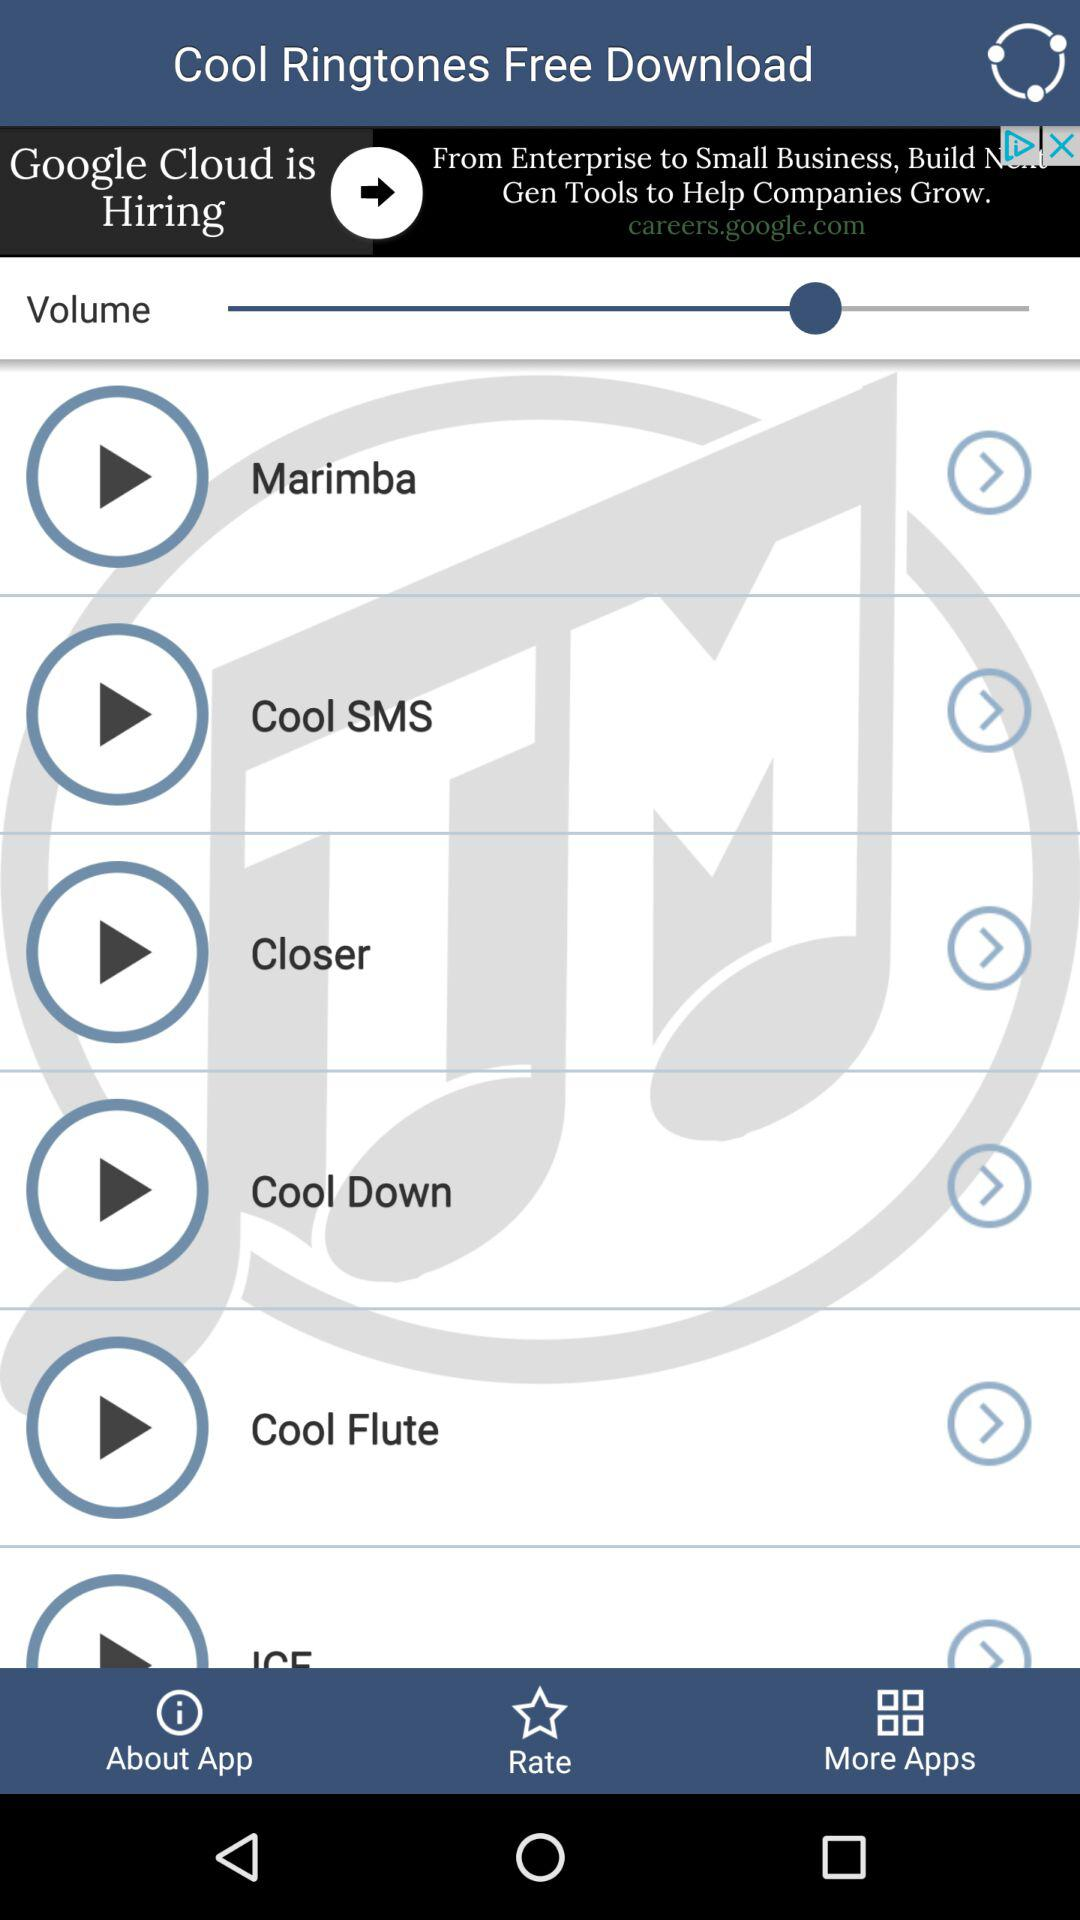What is the application name? The application name is "Cool Ringtones Free Download". 